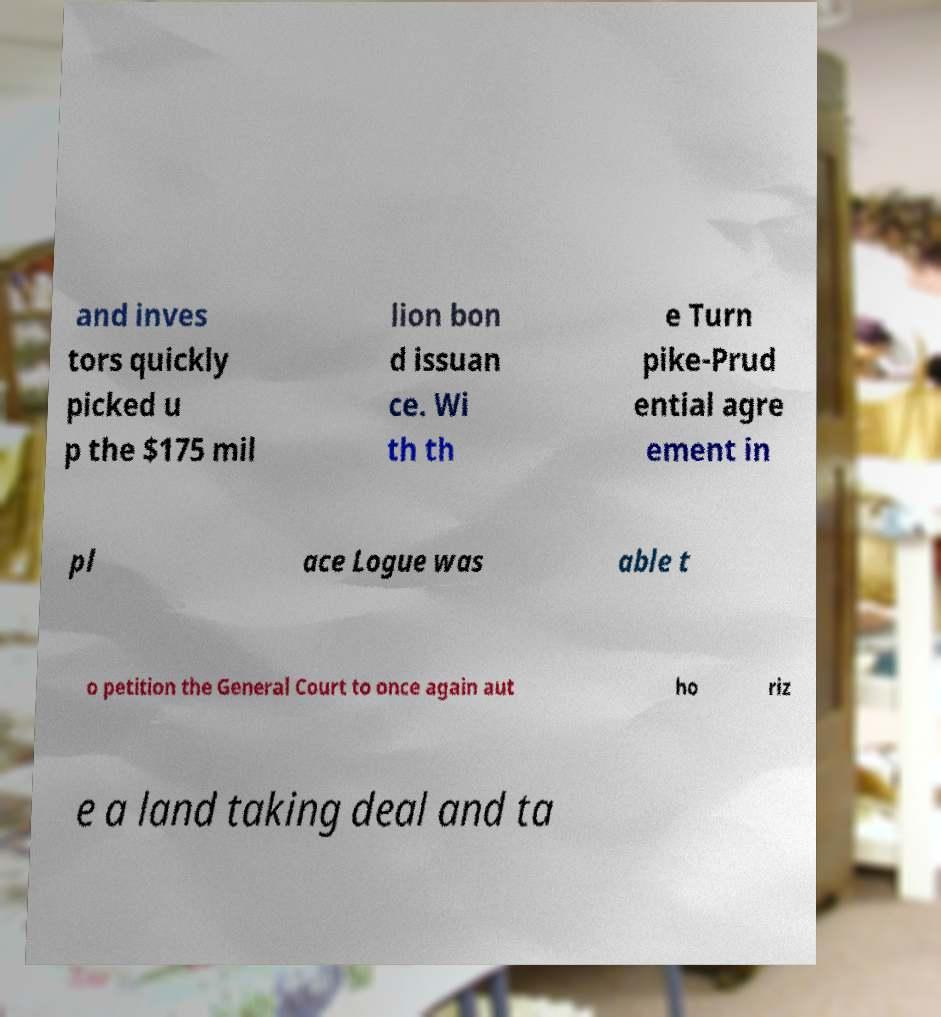Could you assist in decoding the text presented in this image and type it out clearly? and inves tors quickly picked u p the $175 mil lion bon d issuan ce. Wi th th e Turn pike-Prud ential agre ement in pl ace Logue was able t o petition the General Court to once again aut ho riz e a land taking deal and ta 